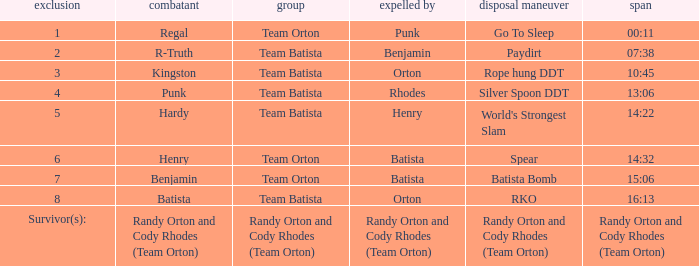Which Elimination move is listed against Team Orton, Eliminated by Batista against Elimination number 7? Batista Bomb. 